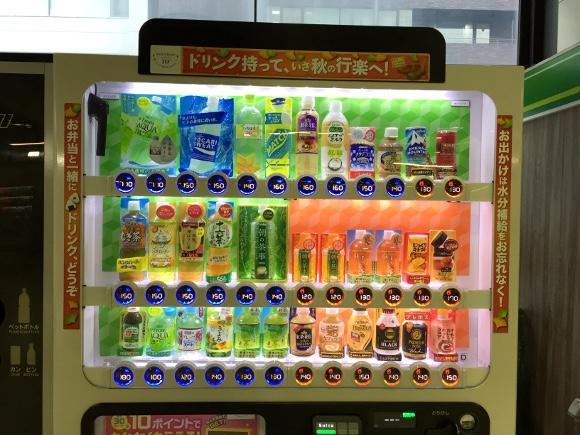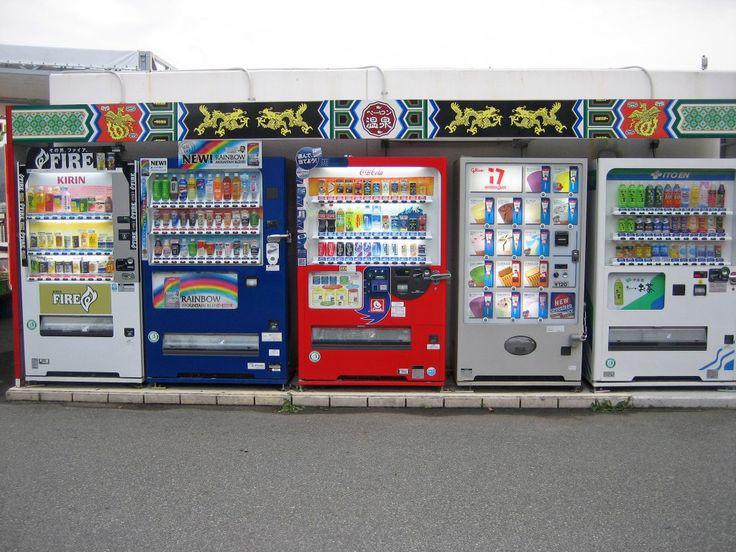The first image is the image on the left, the second image is the image on the right. Examine the images to the left and right. Is the description "An image shows a row of red, white and blue vending machines." accurate? Answer yes or no. Yes. The first image is the image on the left, the second image is the image on the right. Given the left and right images, does the statement "At least one of the machines is bright red." hold true? Answer yes or no. Yes. 